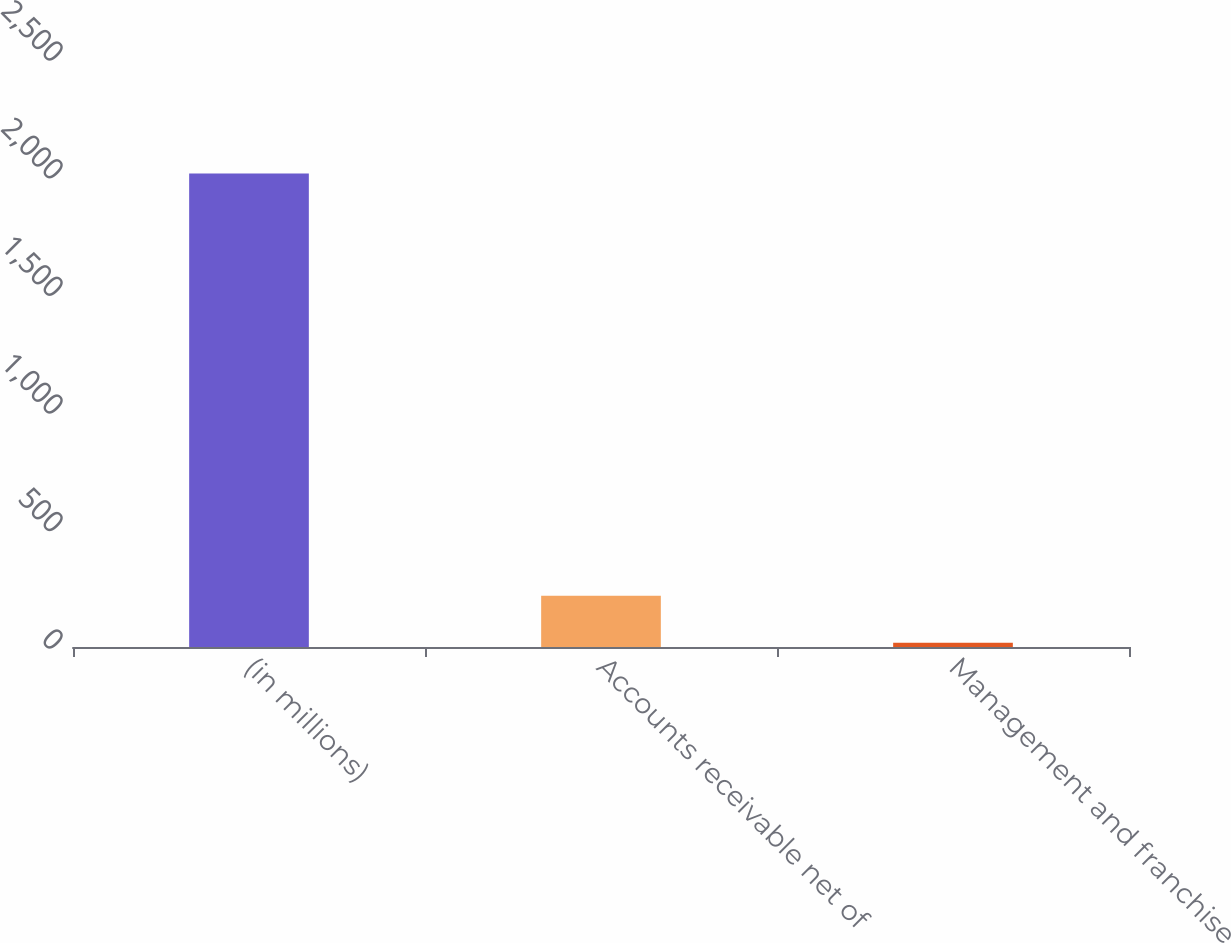Convert chart to OTSL. <chart><loc_0><loc_0><loc_500><loc_500><bar_chart><fcel>(in millions)<fcel>Accounts receivable net of<fcel>Management and franchise<nl><fcel>2013<fcel>217.5<fcel>18<nl></chart> 